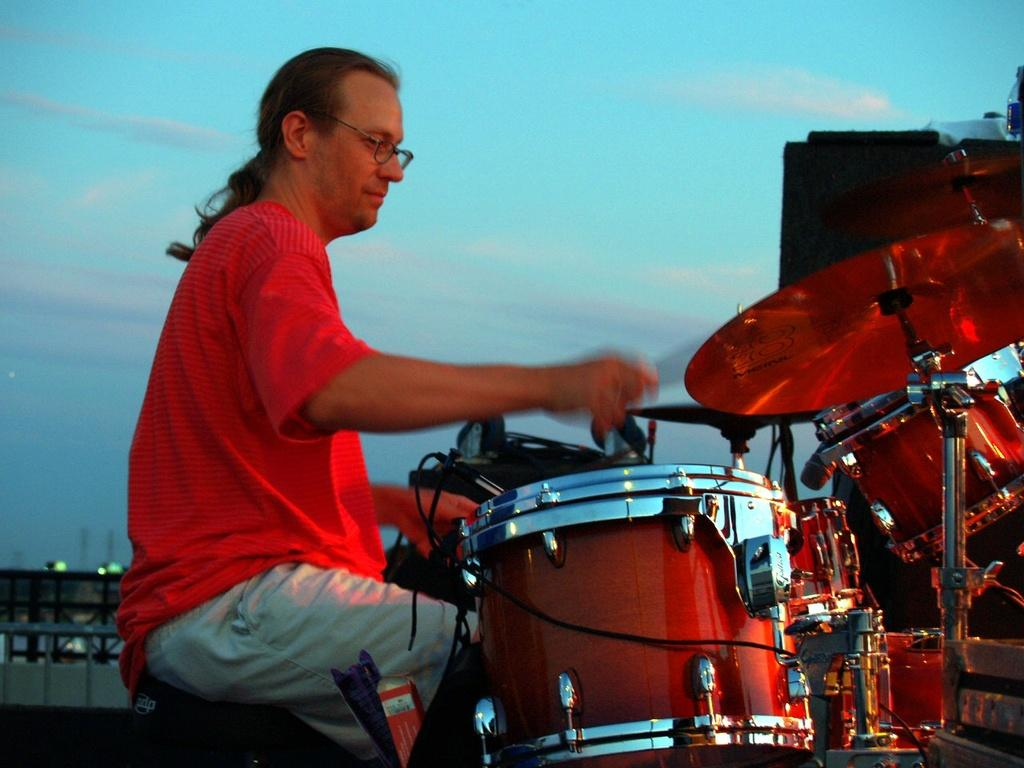What is the man in the image doing? The man is playing drums. What is the man wearing in the image? The man is wearing a red T-shirt. What can be seen in the background of the image? There are clouds in the sky in the background of the image. What type of mint is growing near the man in the image? There is no mint present in the image; it features a man playing drums with clouds in the sky in the background. 